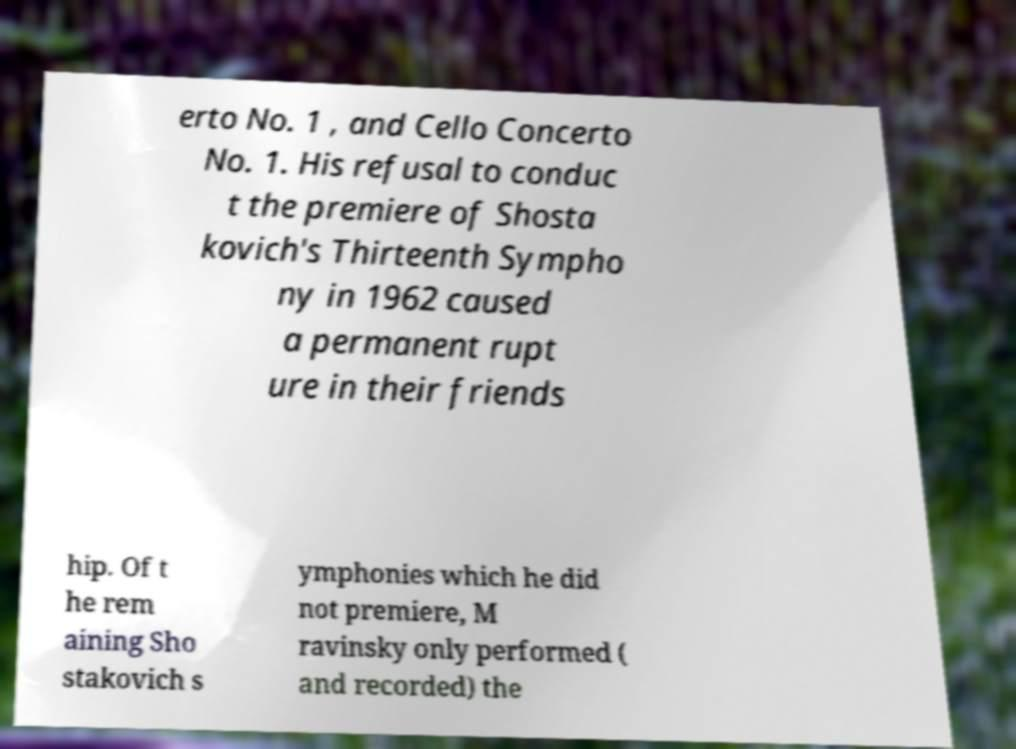What messages or text are displayed in this image? I need them in a readable, typed format. erto No. 1 , and Cello Concerto No. 1. His refusal to conduc t the premiere of Shosta kovich's Thirteenth Sympho ny in 1962 caused a permanent rupt ure in their friends hip. Of t he rem aining Sho stakovich s ymphonies which he did not premiere, M ravinsky only performed ( and recorded) the 